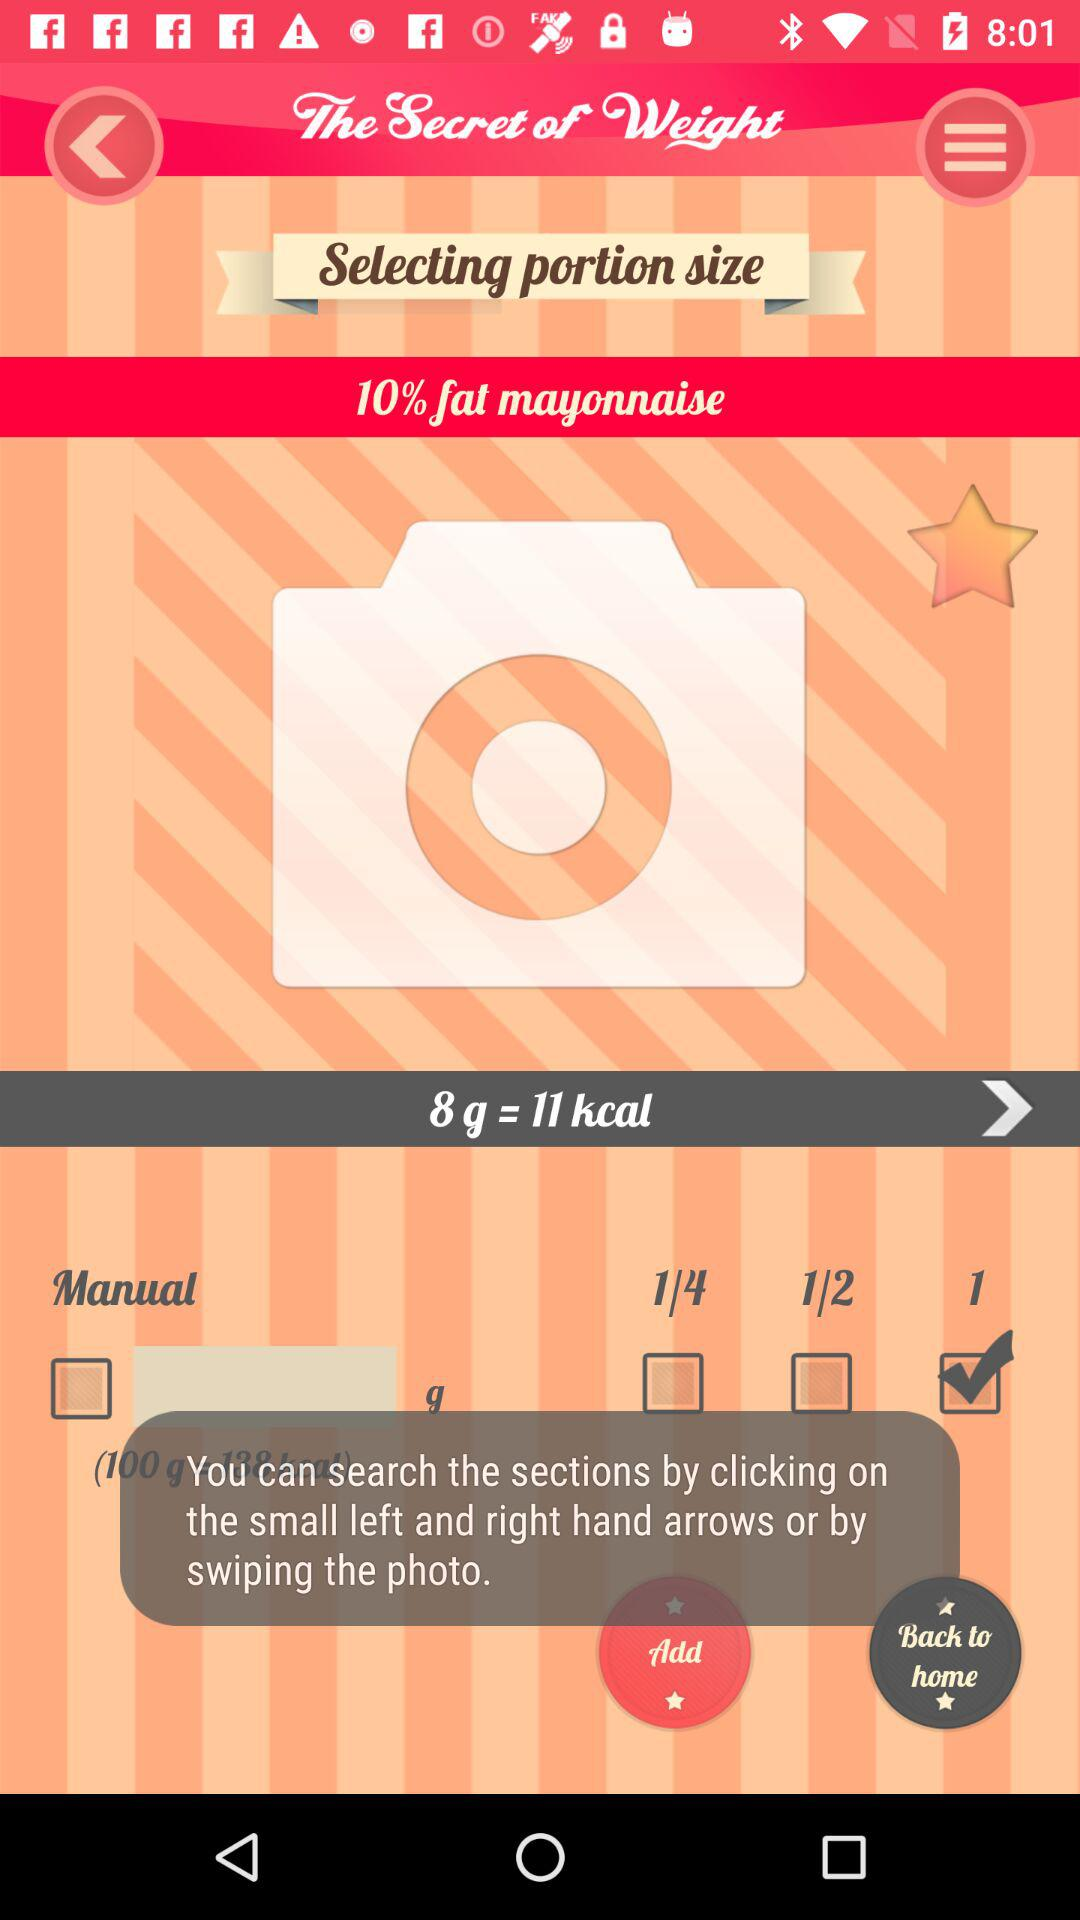How many kcal are there in 8 g of "mayonnaise"? There are 11 kcal in 8 g of "mayonnaise". 